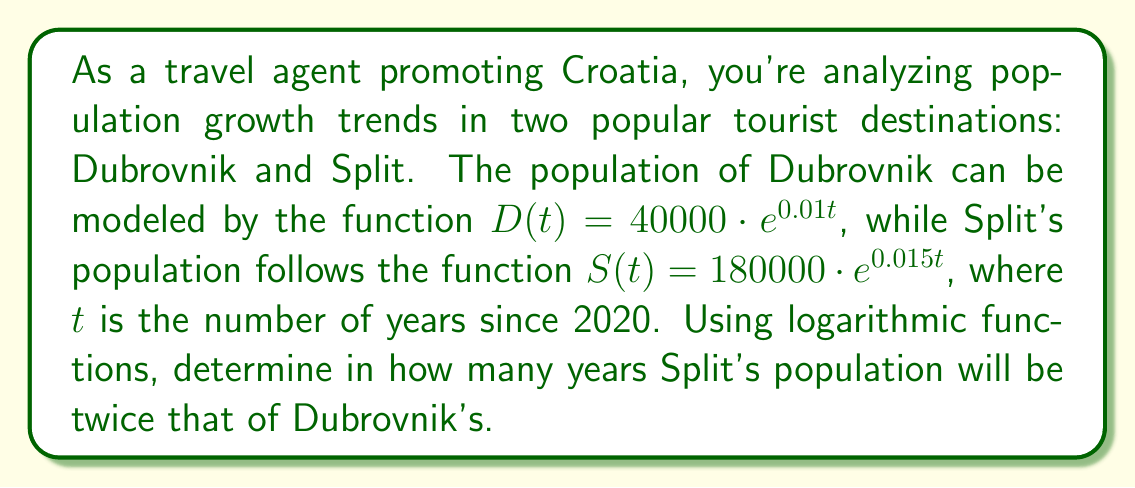Help me with this question. Let's approach this step-by-step:

1) We need to find $t$ when $S(t) = 2D(t)$

2) Let's set up the equation:
   $180000 \cdot e^{0.015t} = 2(40000 \cdot e^{0.01t})$

3) Simplify the right side:
   $180000 \cdot e^{0.015t} = 80000 \cdot e^{0.01t}$

4) Divide both sides by 80000:
   $2.25 \cdot e^{0.015t} = e^{0.01t}$

5) Take the natural log of both sides:
   $\ln(2.25) + 0.015t = 0.01t$

6) Simplify:
   $\ln(2.25) = 0.01t - 0.015t = -0.005t$

7) Solve for $t$:
   $t = \frac{\ln(2.25)}{-0.005} = \frac{\ln(2.25)}{0.005} \approx 162.24$

Therefore, it will take approximately 162.24 years from 2020 for Split's population to be twice that of Dubrovnik's.
Answer: Approximately 162.24 years 